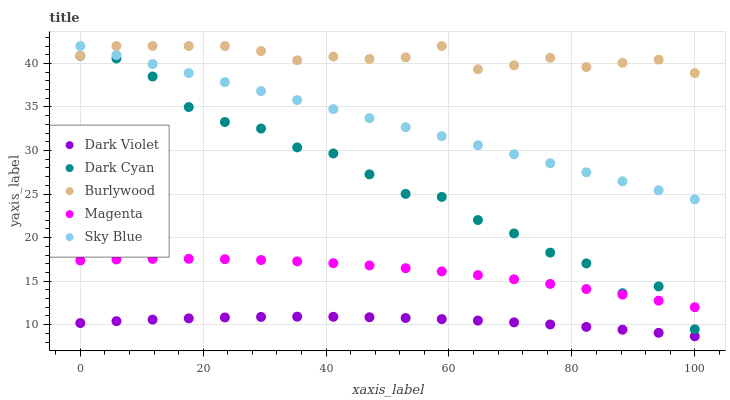Does Dark Violet have the minimum area under the curve?
Answer yes or no. Yes. Does Burlywood have the maximum area under the curve?
Answer yes or no. Yes. Does Magenta have the minimum area under the curve?
Answer yes or no. No. Does Magenta have the maximum area under the curve?
Answer yes or no. No. Is Sky Blue the smoothest?
Answer yes or no. Yes. Is Dark Cyan the roughest?
Answer yes or no. Yes. Is Burlywood the smoothest?
Answer yes or no. No. Is Burlywood the roughest?
Answer yes or no. No. Does Dark Violet have the lowest value?
Answer yes or no. Yes. Does Magenta have the lowest value?
Answer yes or no. No. Does Sky Blue have the highest value?
Answer yes or no. Yes. Does Magenta have the highest value?
Answer yes or no. No. Is Dark Violet less than Magenta?
Answer yes or no. Yes. Is Sky Blue greater than Dark Violet?
Answer yes or no. Yes. Does Sky Blue intersect Burlywood?
Answer yes or no. Yes. Is Sky Blue less than Burlywood?
Answer yes or no. No. Is Sky Blue greater than Burlywood?
Answer yes or no. No. Does Dark Violet intersect Magenta?
Answer yes or no. No. 